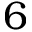<formula> <loc_0><loc_0><loc_500><loc_500>6</formula> 